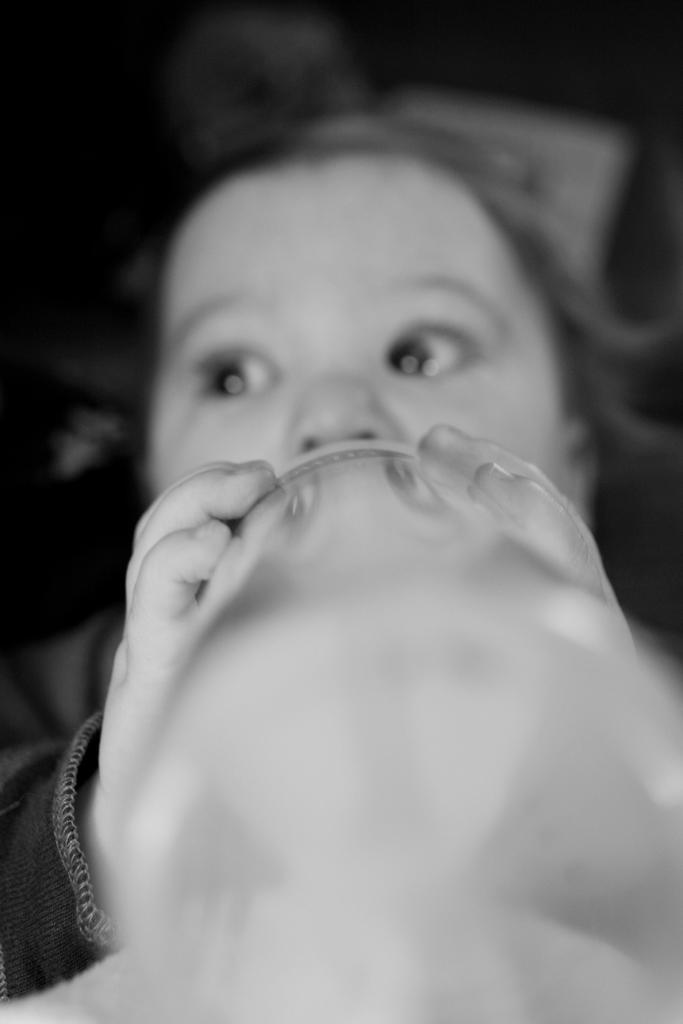What is the main subject of the image? There is a baby in the image. What is the baby holding in the image? The baby is holding a bottle. Can you describe the background of the image? The background of the image is blurred. How many kittens can be seen playing with the baby in the image? There are no kittens present in the image; it only features a baby holding a bottle. 